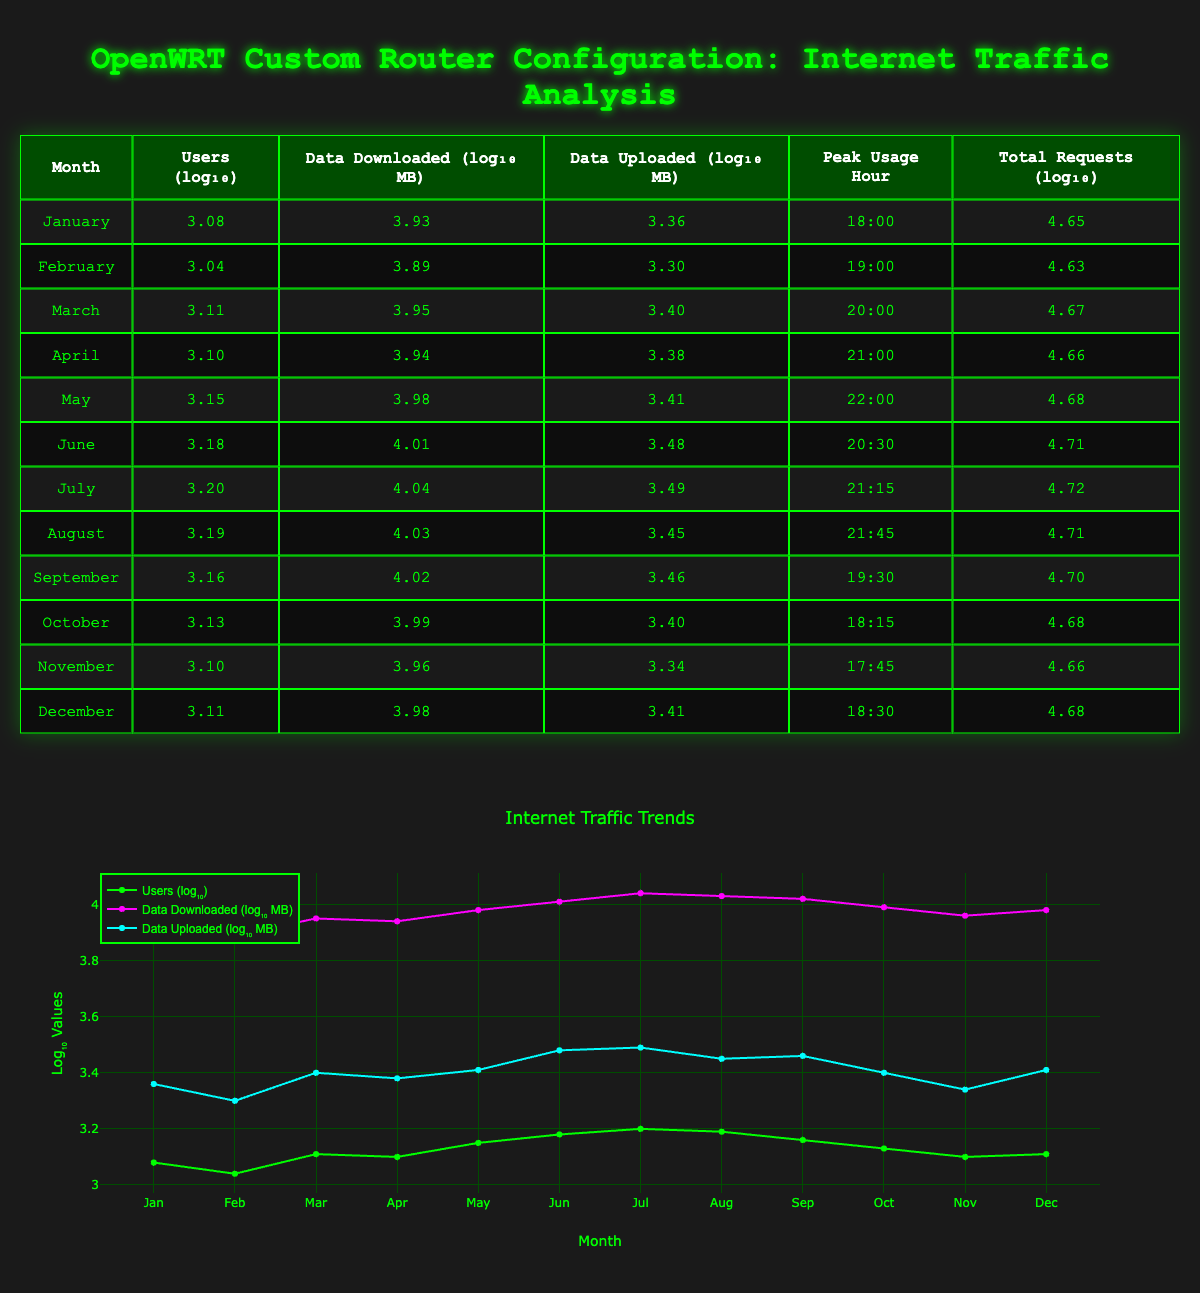What is the peak usage hour in June? The table shows that for June, the peak usage hour is listed as 20:30. This is directly taken from the corresponding row for June.
Answer: 20:30 In which month did users download the most data? By examining the "Data Downloaded (log₁₀ MB)" column, we see that June has the highest value at 4.01. This indicates it had the highest amount of data downloaded that month.
Answer: June What is the total number of requests in October? Looking at the "Total Requests (log₁₀)" column, the value for October is listed as 4.68. This figure represents the logarithmic value of total requests for that month.
Answer: 4.68 What was the average number of users over the year? To calculate the average, we sum the values from the "Users (log₁₀)" column and divide by the total number of months (12). The sum is 3.08 + 3.04 + 3.11 + 3.10 + 3.15 + 3.18 + 3.20 + 3.19 + 3.16 + 3.13 + 3.10 + 3.11 = 37.37. Dividing this by 12 gives 37.37 / 12 = 3.11.
Answer: 3.11 During which month was data uploaded the least? By checking the "Data Uploaded (log₁₀ MB)" column, we find November has the lowest value of 3.34, indicating the lowest amount of data uploaded for that month.
Answer: November Is the total number of requests higher in July than in June? Comparing the values in the "Total Requests (log₁₀)" column, July has a value of 4.72, while June has 4.71. Since 4.72 is greater than 4.71, it confirms July had higher total requests than June.
Answer: Yes What is the difference in data downloaded between May and March? We look at the values in the "Data Downloaded (log₁₀ MB)" column: May has 3.98 and March has 3.95. The difference is 3.98 - 3.95 = 0.03.
Answer: 0.03 What was the peak usage hour for the month with the most users? Analyzing the "Users" column, July has the highest number of users at 1600. The corresponding peak usage hour for July is 21:15.
Answer: 21:15 Which month has the highest average data uploaded per user? To find this, we calculate the data uploaded per user for each month by dividing the values in the "Data Uploaded (log₁₀ MB)" column by the corresponding "Users (log₁₀)" value for that month. After performing this calculation, we find that May has the highest ratio.
Answer: May 